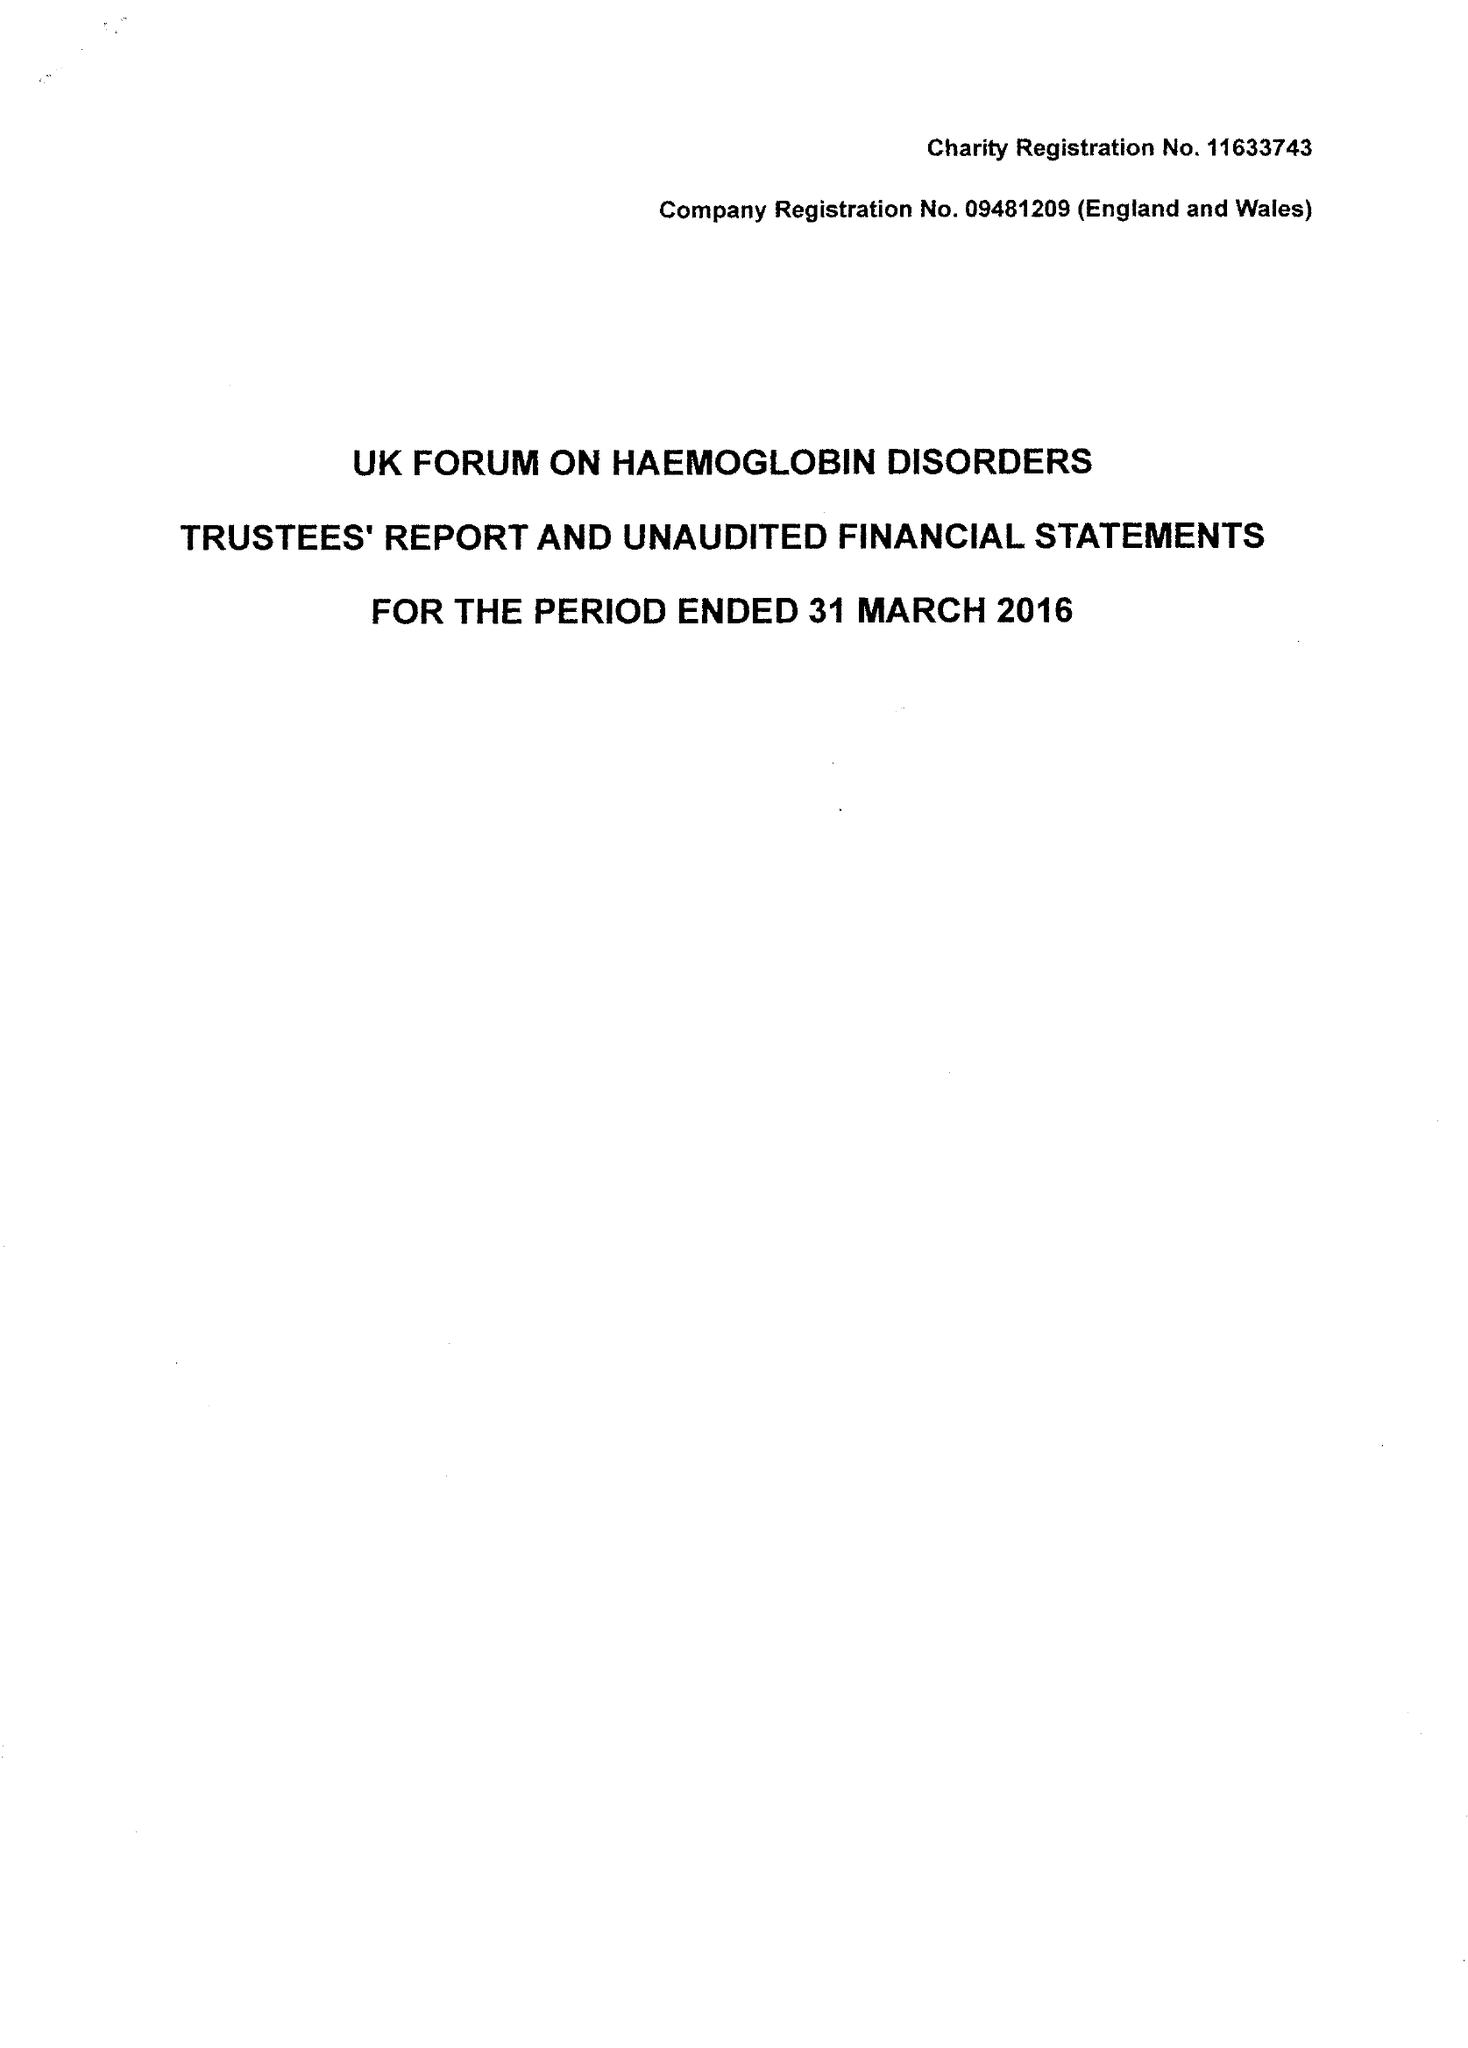What is the value for the address__street_line?
Answer the question using a single word or phrase. GREAT MAZE POND 